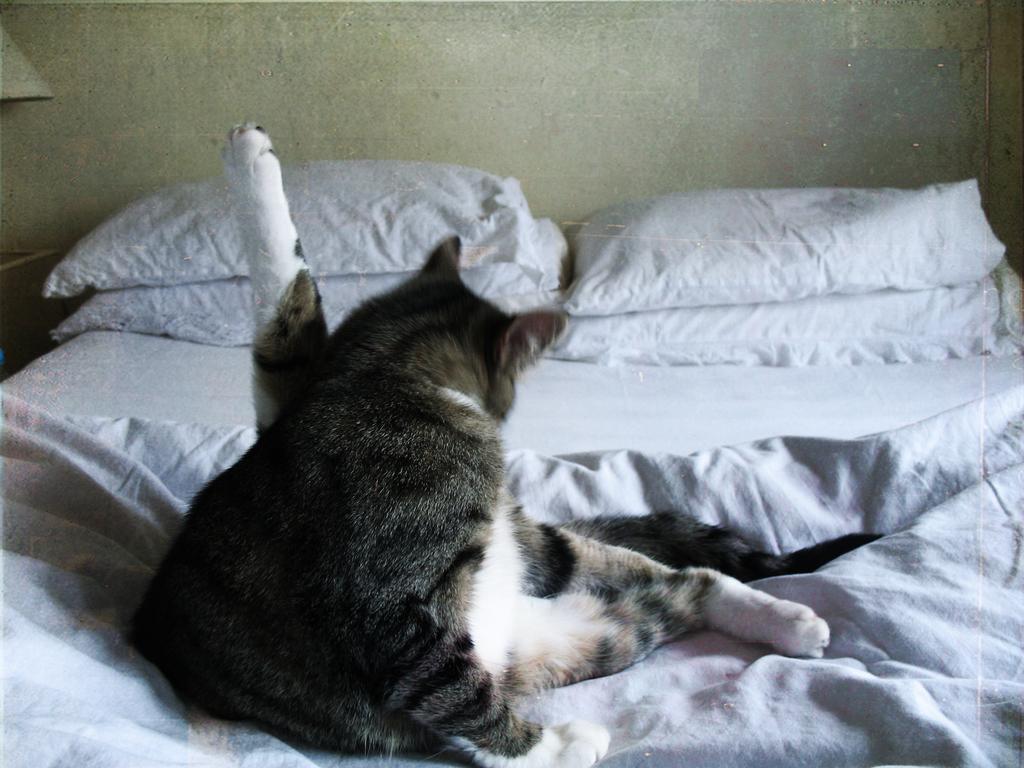In one or two sentences, can you explain what this image depicts? This cat is sitting on this bed and we can able to see pillows on this bed. 